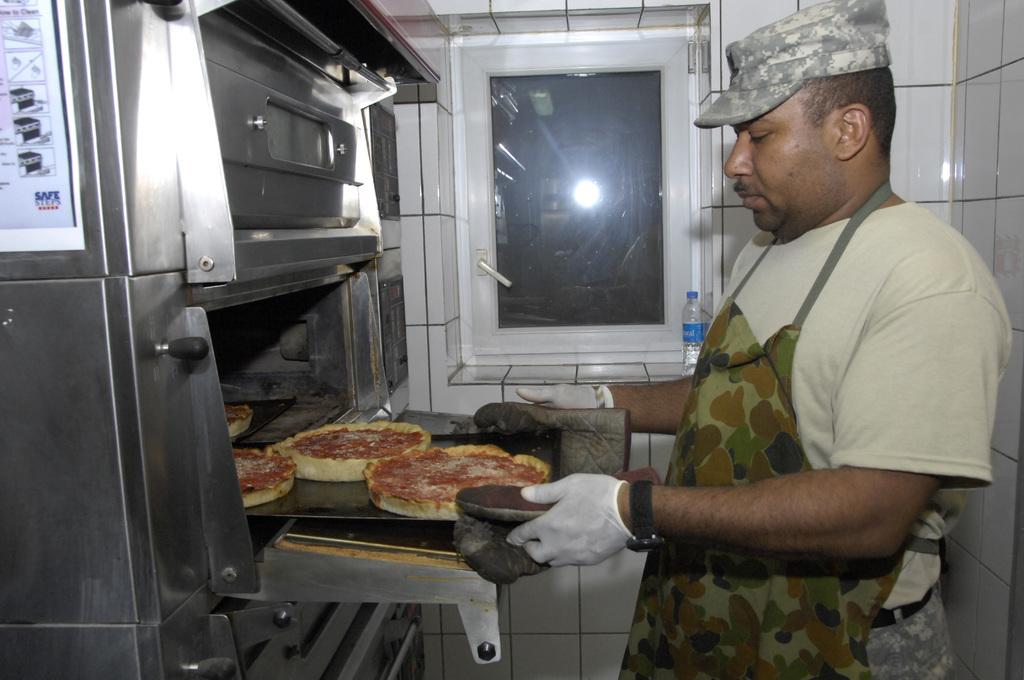Provide a one-sentence caption for the provided image. a safe sheet of paper next to a guy cooking. 